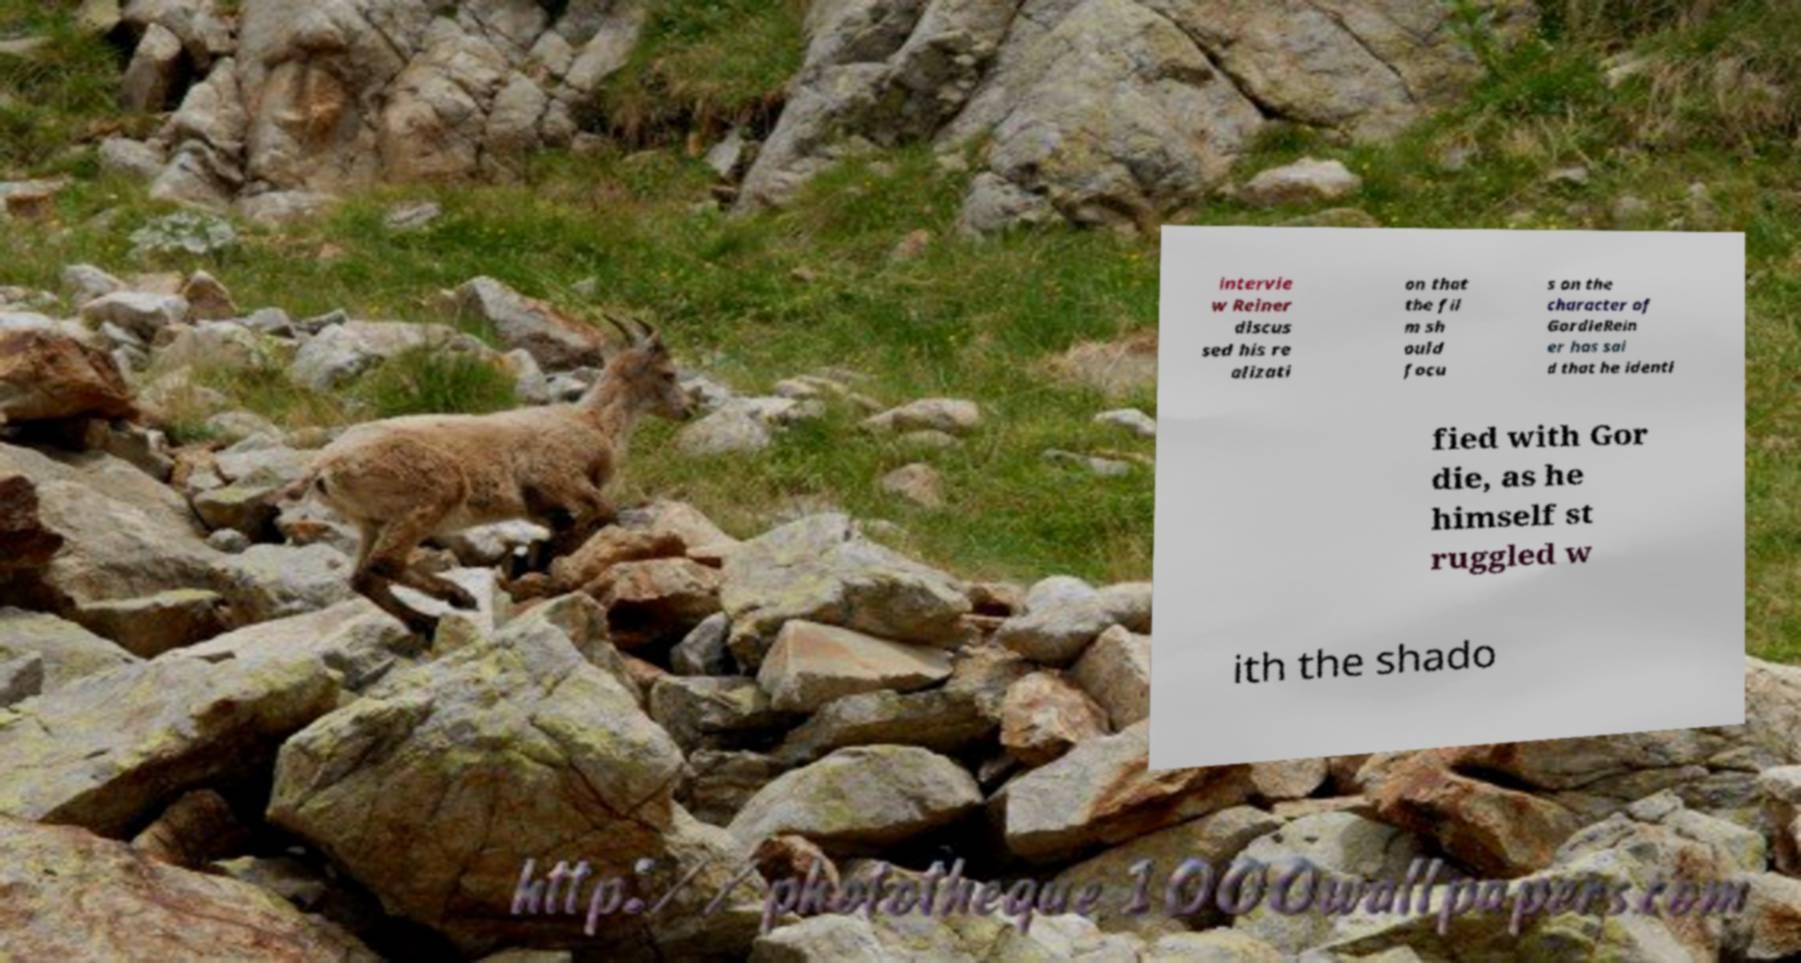I need the written content from this picture converted into text. Can you do that? intervie w Reiner discus sed his re alizati on that the fil m sh ould focu s on the character of GordieRein er has sai d that he identi fied with Gor die, as he himself st ruggled w ith the shado 